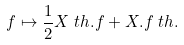Convert formula to latex. <formula><loc_0><loc_0><loc_500><loc_500>f \mapsto \frac { 1 } { 2 } X _ { \ } t h . f + X . f _ { \ } t h .</formula> 